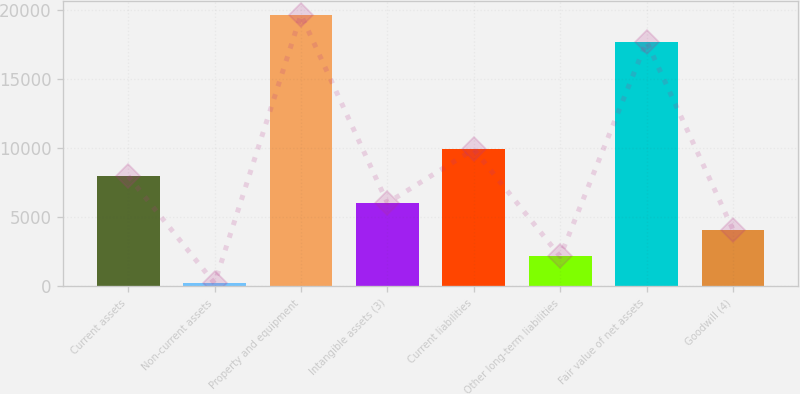Convert chart. <chart><loc_0><loc_0><loc_500><loc_500><bar_chart><fcel>Current assets<fcel>Non-current assets<fcel>Property and equipment<fcel>Intangible assets (3)<fcel>Current liabilities<fcel>Other long-term liabilities<fcel>Fair value of net assets<fcel>Goodwill (4)<nl><fcel>7983.2<fcel>222<fcel>19671.3<fcel>6042.9<fcel>9923.5<fcel>2162.3<fcel>17731<fcel>4102.6<nl></chart> 